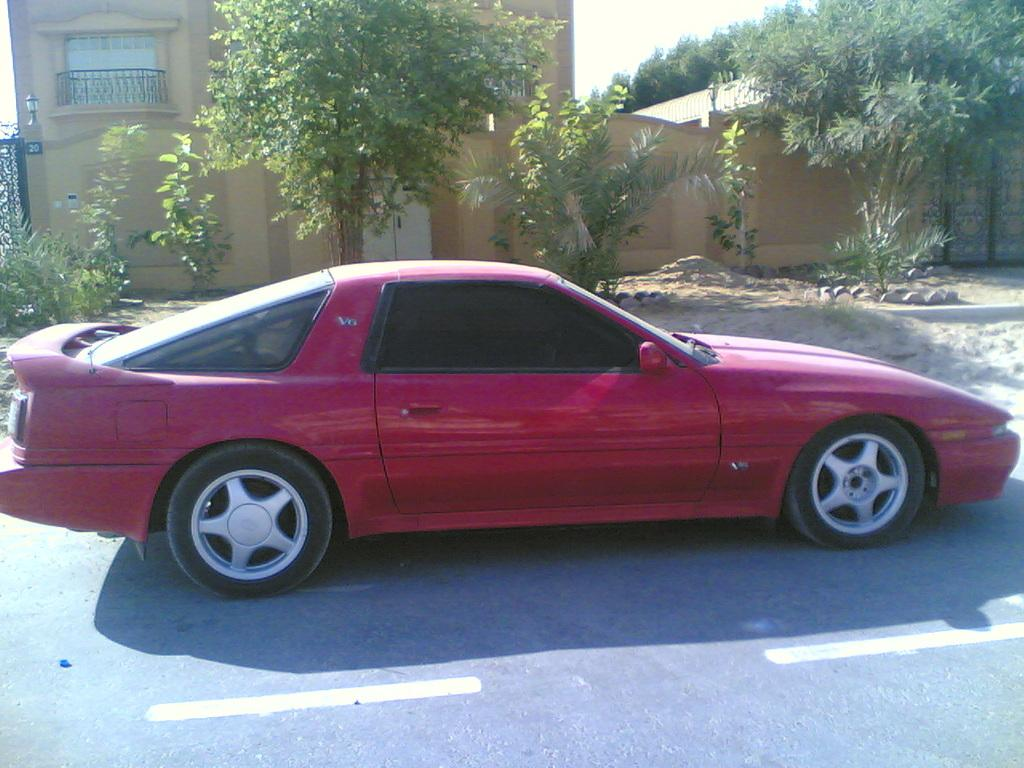What is on the road in the image? There is a vehicle on the road in the image. What can be seen in the background of the image? There is a house in the background of the image. What type of vegetation is visible in the image? Trees are visible in the image. What is located on the left side of the image? There is a metal gate on the left side of the image. What does the vehicle taste like in the image? The vehicle does not have a taste, as it is an inanimate object. 